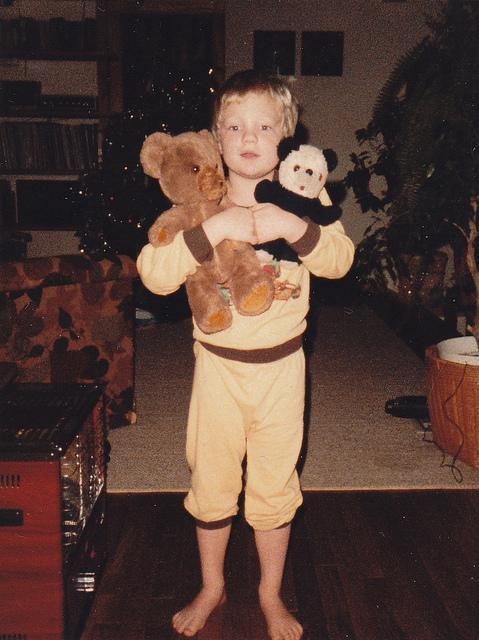Does the image validate the caption "The person is on the couch."?
Answer yes or no. No. 